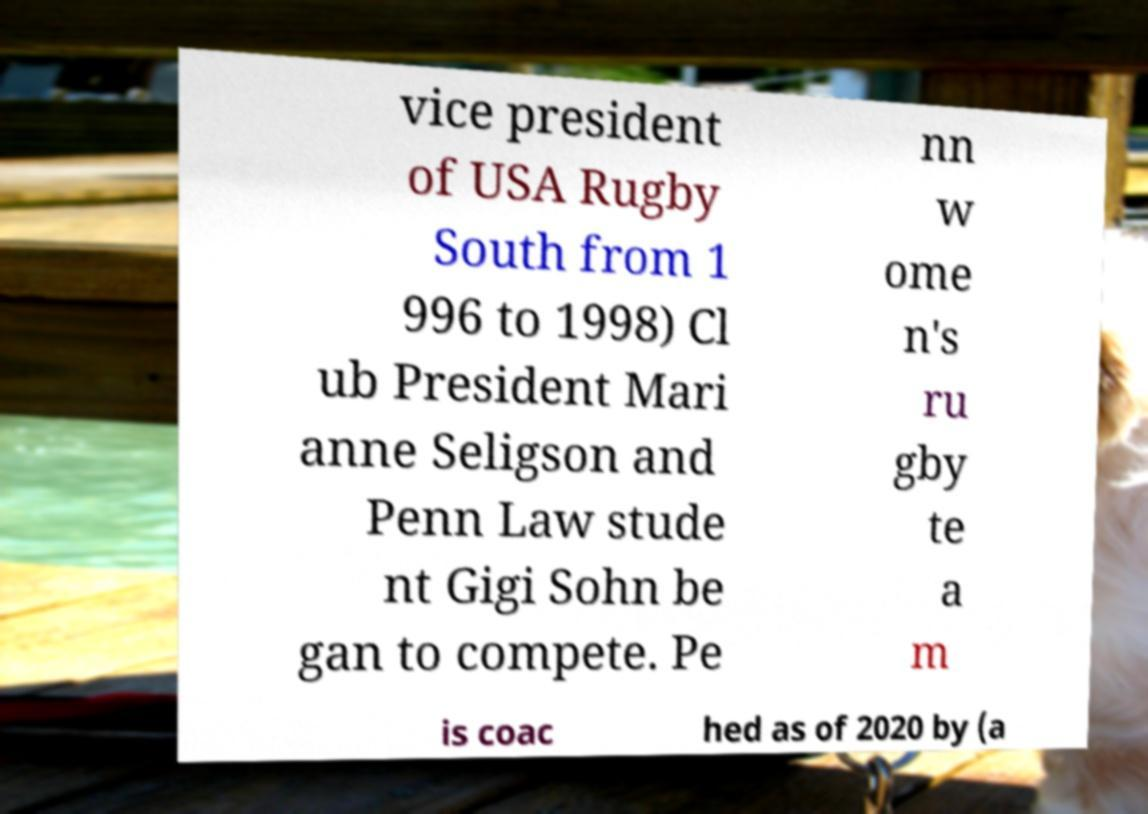Please read and relay the text visible in this image. What does it say? vice president of USA Rugby South from 1 996 to 1998) Cl ub President Mari anne Seligson and Penn Law stude nt Gigi Sohn be gan to compete. Pe nn w ome n's ru gby te a m is coac hed as of 2020 by (a 